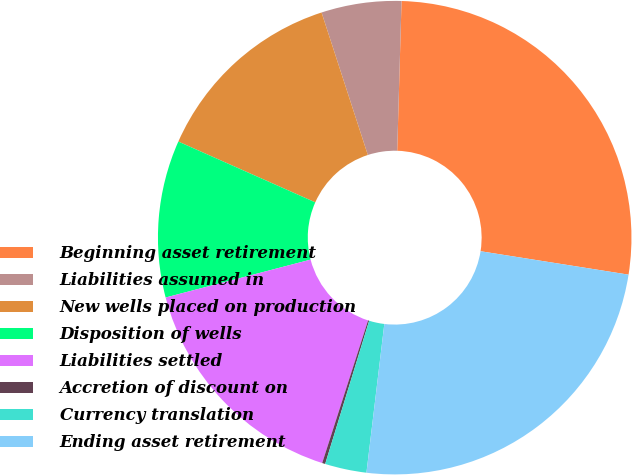Convert chart to OTSL. <chart><loc_0><loc_0><loc_500><loc_500><pie_chart><fcel>Beginning asset retirement<fcel>Liabilities assumed in<fcel>New wells placed on production<fcel>Disposition of wells<fcel>Liabilities settled<fcel>Accretion of discount on<fcel>Currency translation<fcel>Ending asset retirement<nl><fcel>27.04%<fcel>5.46%<fcel>13.35%<fcel>10.72%<fcel>15.98%<fcel>0.21%<fcel>2.84%<fcel>24.41%<nl></chart> 